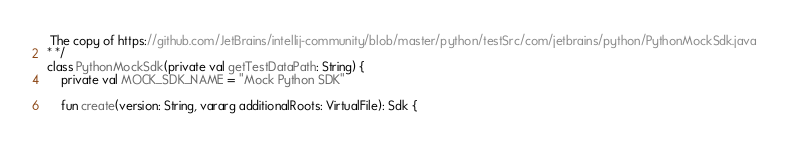<code> <loc_0><loc_0><loc_500><loc_500><_Kotlin_> The copy of https://github.com/JetBrains/intellij-community/blob/master/python/testSrc/com/jetbrains/python/PythonMockSdk.java
* */
class PythonMockSdk(private val getTestDataPath: String) {
    private val MOCK_SDK_NAME = "Mock Python SDK"

    fun create(version: String, vararg additionalRoots: VirtualFile): Sdk {</code> 